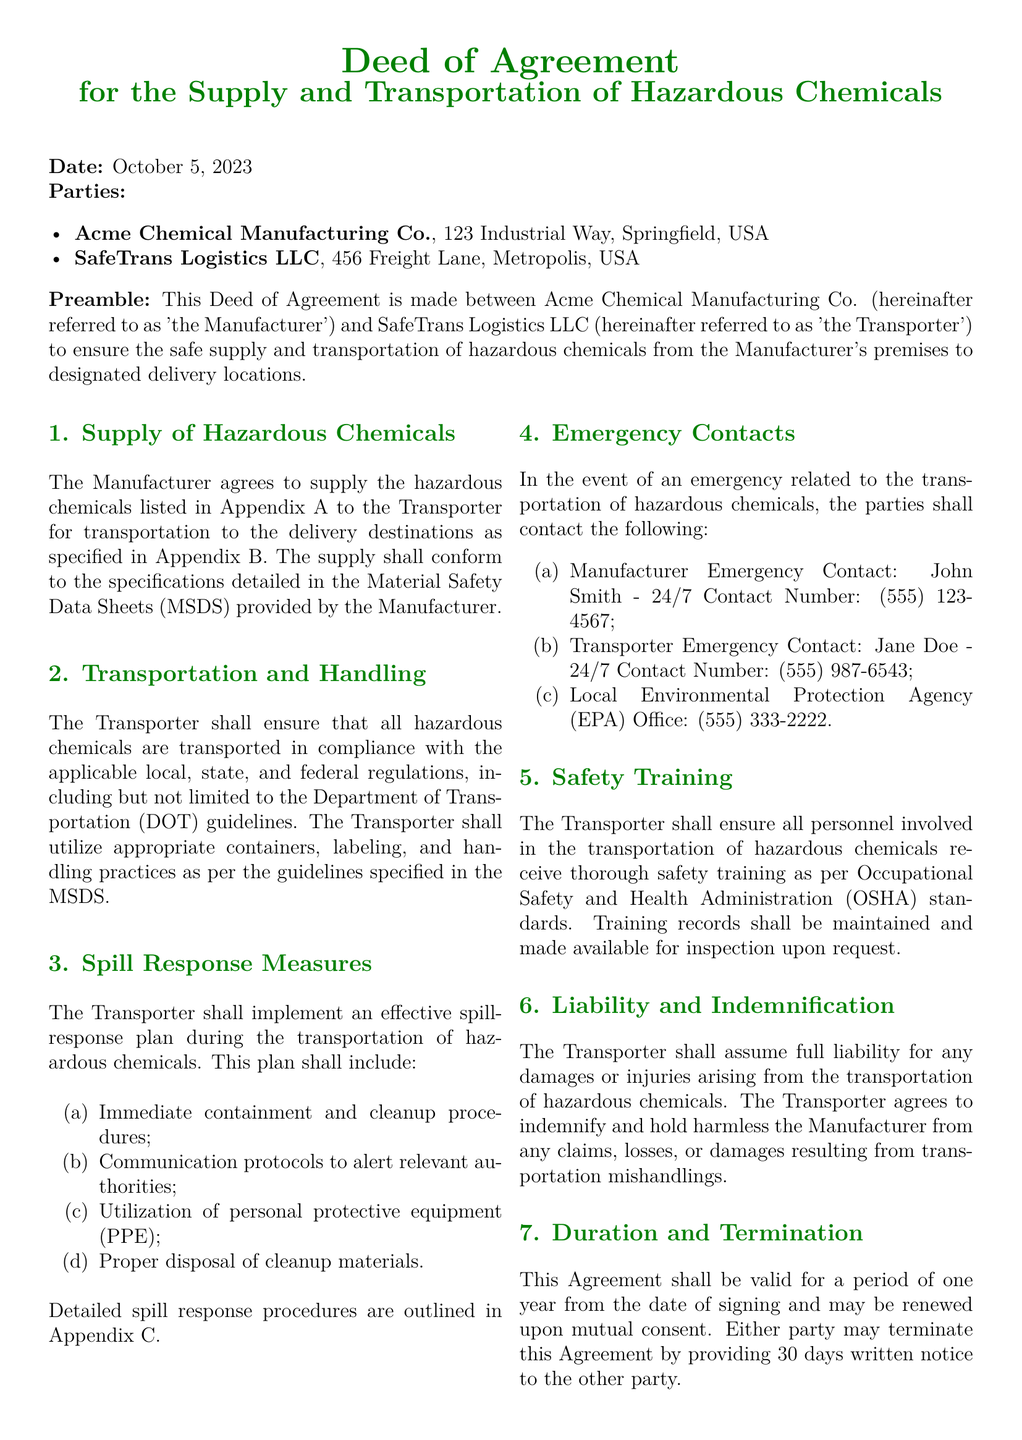What is the date of the agreement? The date of the agreement is stated at the beginning of the document.
Answer: October 5, 2023 Who is the Manufacturer? The Manufacturer is the first party listed in the agreement.
Answer: Acme Chemical Manufacturing Co What are the emergency contact numbers for the Manufacturer? The emergency contact number for the Manufacturer is listed under the Emergency Contacts section.
Answer: (555) 123-4567 What type of training must the Transporter’s personnel receive? The type of training required is specified in the Safety Training section.
Answer: OSHA standards What is the duration of the agreement? The duration of the agreement is detailed in the Duration and Termination section.
Answer: One year What must be included in the spill-response plan? The spill-response plan requirements are listed under the Spill Response Measures section.
Answer: Immediate containment and cleanup procedures How many days notice is required for termination? The notice period for termination is specified in the Duration and Termination section.
Answer: 30 days What is the liability agreement regarding the Transporter? The liability agreement is outlined in the Liability and Indemnification section.
Answer: Assume full liability for damages What organization’s guidelines must the Transporter follow for transportation? The specific guidelines that must be followed are mentioned in the Transportation and Handling section.
Answer: Department of Transportation (DOT) 